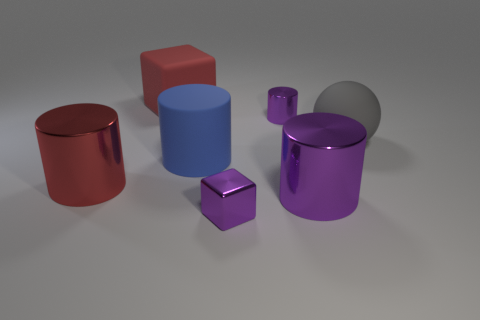Add 3 tiny purple cubes. How many objects exist? 10 Subtract all purple cylinders. How many cylinders are left? 2 Subtract all blue cylinders. How many cylinders are left? 3 Subtract 1 cubes. How many cubes are left? 1 Subtract all large rubber things. Subtract all small purple objects. How many objects are left? 2 Add 3 red shiny objects. How many red shiny objects are left? 4 Add 1 purple shiny things. How many purple shiny things exist? 4 Subtract 0 cyan balls. How many objects are left? 7 Subtract all cylinders. How many objects are left? 3 Subtract all green spheres. Subtract all yellow blocks. How many spheres are left? 1 